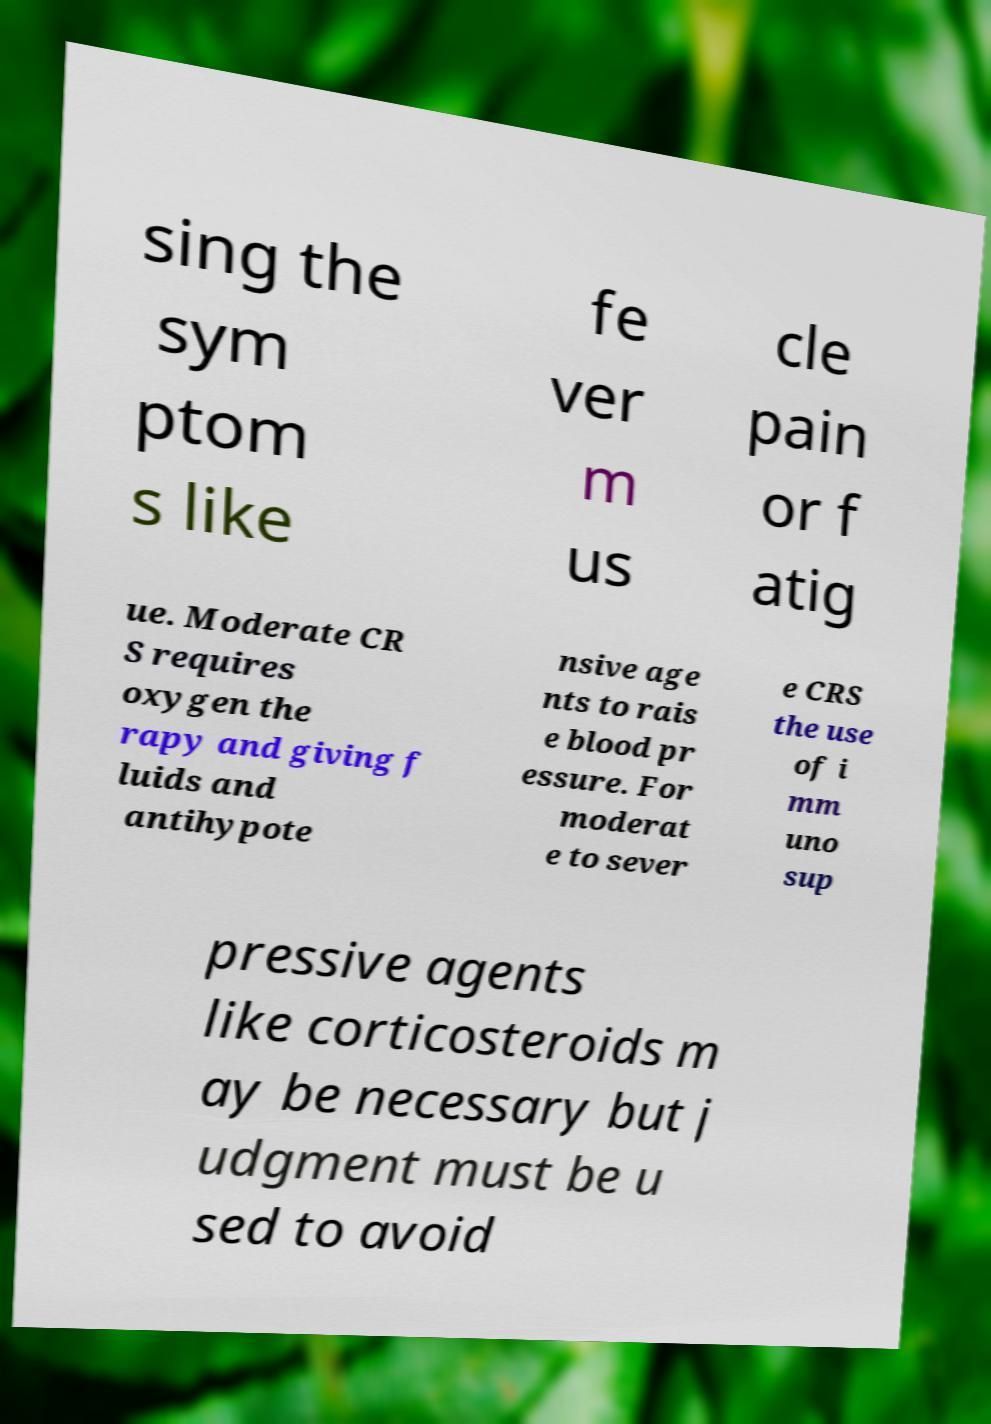Can you read and provide the text displayed in the image?This photo seems to have some interesting text. Can you extract and type it out for me? sing the sym ptom s like fe ver m us cle pain or f atig ue. Moderate CR S requires oxygen the rapy and giving f luids and antihypote nsive age nts to rais e blood pr essure. For moderat e to sever e CRS the use of i mm uno sup pressive agents like corticosteroids m ay be necessary but j udgment must be u sed to avoid 